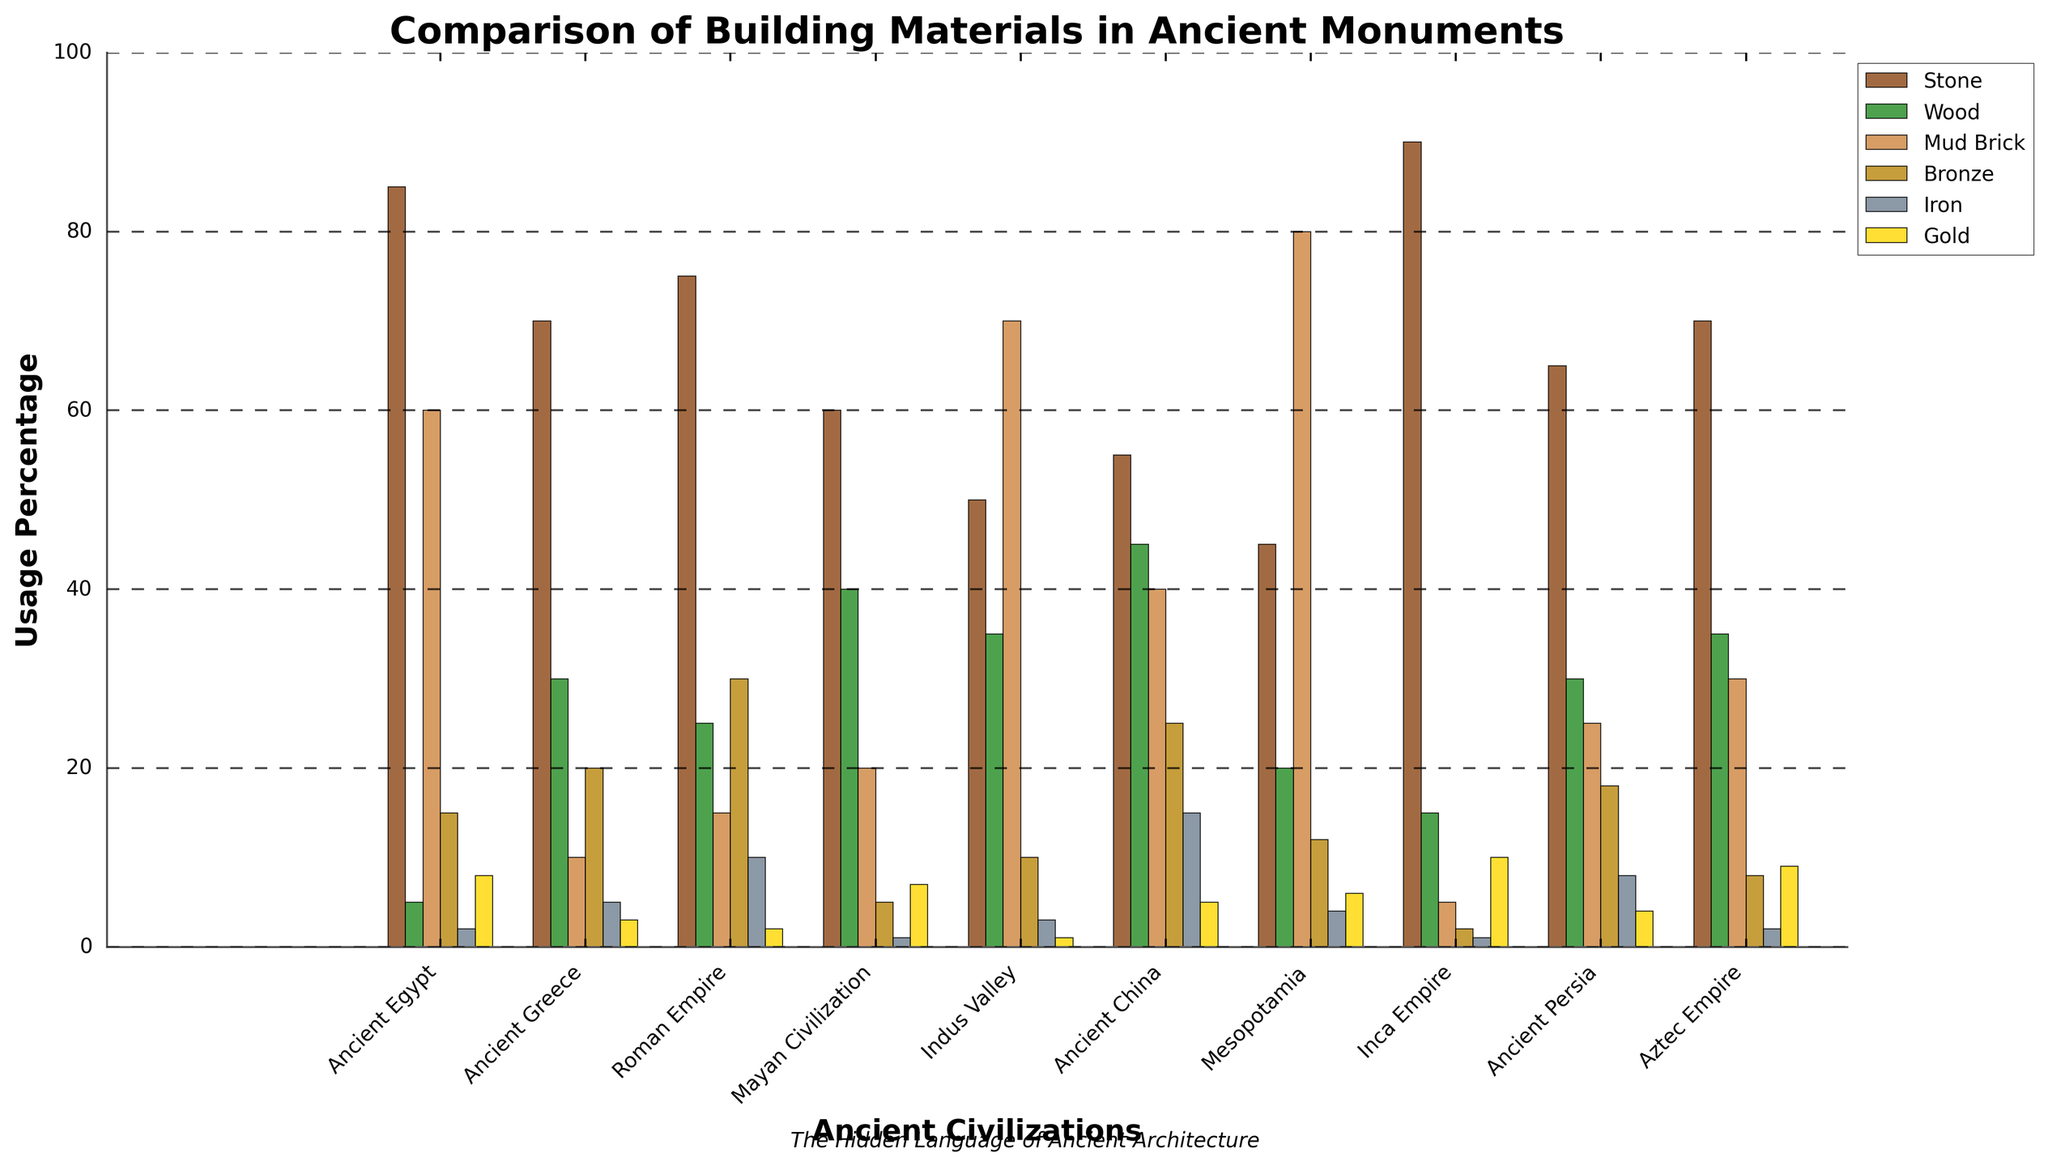What material does the Inca Empire use most extensively in their monuments? The material that is represented by the highest bar for the Inca Empire is Stone, which clearly exceeds all other materials in height.
Answer: Stone Which civilization uses Mud Brick the most in their constructions? The tallest bar for Mud Brick across all civilizations is found in Mesopotamia.
Answer: Mesopotamia Compare the usage of Wood between Ancient Greece and Ancient China. Which civilization uses it more? The bars representing Wood values for Ancient Greece and Ancient China show that Ancient China has a taller bar than Ancient Greece.
Answer: Ancient China What is the sum of the usage percentages of Iron and Gold in the Aztec Empire? The bar for Iron in the Aztec Empire is 2, and the bar for Gold is 9. Adding these two values gives 2 + 9.
Answer: 11 Which two civilizations use Stone almost equally? The bars for Stone in Ancient Greece and Aztec Empire are nearly identical in height.
Answer: Ancient Greece, Aztec Empire What is the visual difference between the use of Bronze in the Roman Empire and in Mayan Civilization? The bar for Bronze in the Roman Empire is much taller than that in the Mayan Civilization, indicating a significantly higher usage of Bronze in the Roman Empire.
Answer: Roman Empire uses more Bronze Which material is used least by the Mayan Civilization? The shortest bar for the Mayan Civilization is for Iron.
Answer: Iron What can you infer about the use of materials in Ancient Egypt compared to the Indus Valley? Ancient Egypt has the highest use of Stone and prominently uses Mud Brick, while the Indus Valley uses more Mud Brick and has a relatively even distribution among other materials compared to Ancient Egypt.
Answer: Ancient Egypt uses more Stone, Indus Valley uses more Mud Brick How do the percentages of Wood and Mud Brick usage compare for Ancient China? The bar for Wood in Ancient China is slightly higher than the bar for Mud Brick, indicating that Wood is used more than Mud Brick.
Answer: Wood is used more What does the height of the bar for Gold usage in the Inca Empire suggest about their architecture? The comparatively tall bar for Gold usage in Inca Empire suggests they incorporated a notable amount of Gold in their monuments.
Answer: Gold is significantly used 